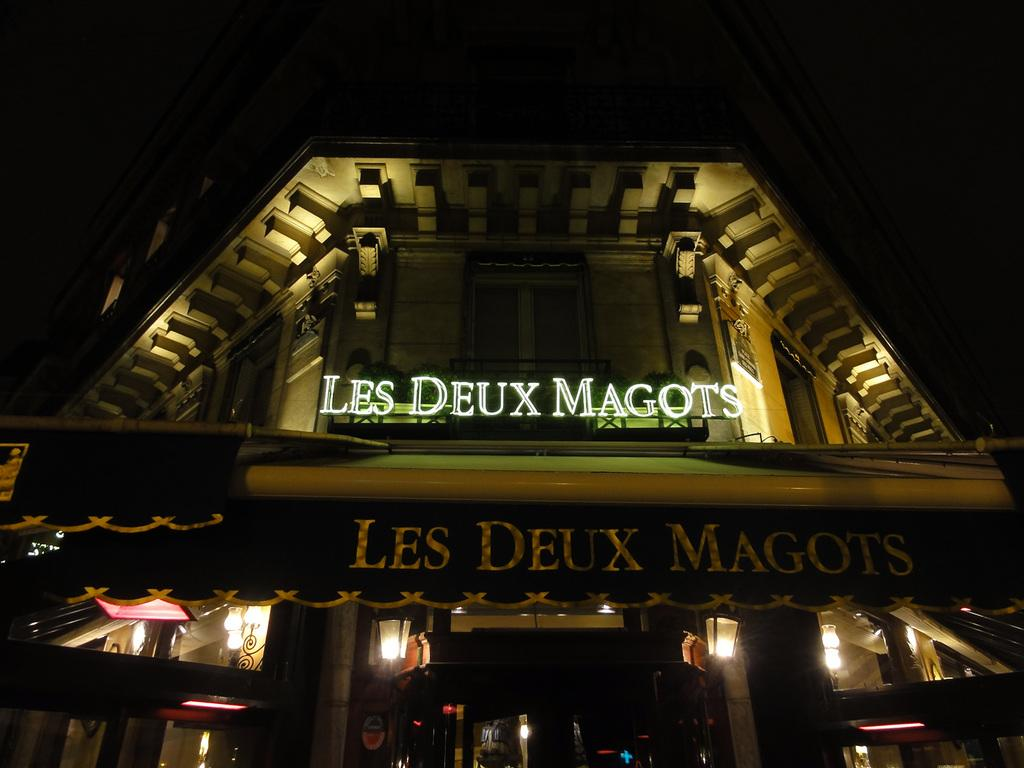What type of structure is present in the image? There is a building in the image. What feature of the building is mentioned in the facts? The building has a 3D name board. What other objects can be seen in the image? There are lamps in the image. Is there a lawyer standing next to the building in the image? There is no mention of a lawyer or any person in the image, so we cannot determine if there is one present. 